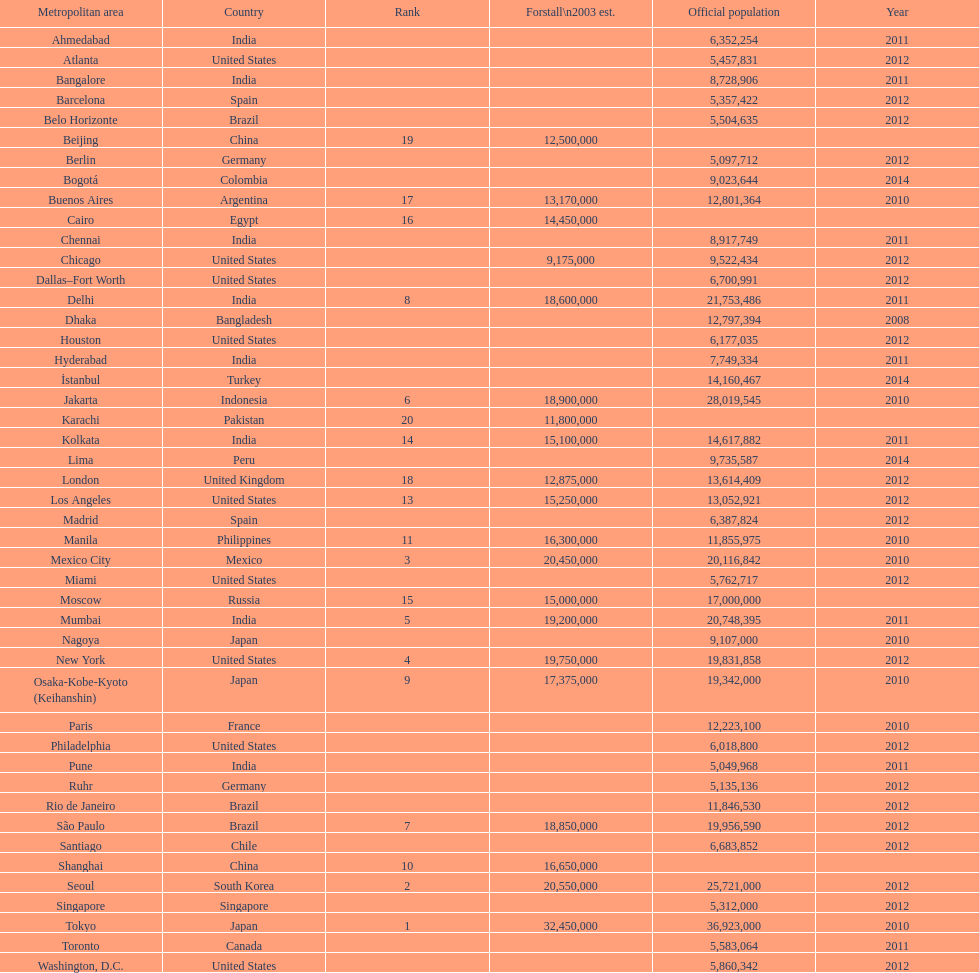What population comes before 5,357,422? 8,728,906. 